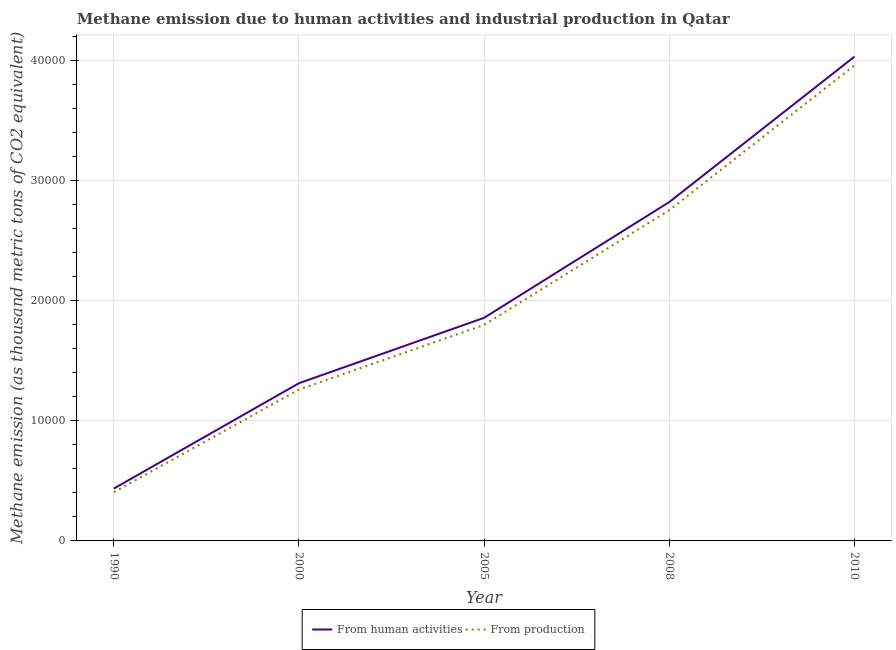How many different coloured lines are there?
Your response must be concise. 2. What is the amount of emissions from human activities in 2010?
Ensure brevity in your answer.  4.03e+04. Across all years, what is the maximum amount of emissions from human activities?
Make the answer very short. 4.03e+04. Across all years, what is the minimum amount of emissions generated from industries?
Offer a very short reply. 4055.8. In which year was the amount of emissions generated from industries minimum?
Ensure brevity in your answer.  1990. What is the total amount of emissions generated from industries in the graph?
Your answer should be very brief. 1.02e+05. What is the difference between the amount of emissions generated from industries in 2000 and that in 2005?
Make the answer very short. -5388.1. What is the difference between the amount of emissions generated from industries in 2010 and the amount of emissions from human activities in 1990?
Ensure brevity in your answer.  3.52e+04. What is the average amount of emissions from human activities per year?
Provide a short and direct response. 2.09e+04. In the year 2008, what is the difference between the amount of emissions generated from industries and amount of emissions from human activities?
Provide a succinct answer. -677. What is the ratio of the amount of emissions from human activities in 2005 to that in 2008?
Offer a terse response. 0.66. Is the amount of emissions generated from industries in 1990 less than that in 2000?
Make the answer very short. Yes. Is the difference between the amount of emissions generated from industries in 2005 and 2010 greater than the difference between the amount of emissions from human activities in 2005 and 2010?
Offer a terse response. Yes. What is the difference between the highest and the second highest amount of emissions generated from industries?
Your response must be concise. 1.21e+04. What is the difference between the highest and the lowest amount of emissions generated from industries?
Your answer should be very brief. 3.55e+04. In how many years, is the amount of emissions generated from industries greater than the average amount of emissions generated from industries taken over all years?
Your response must be concise. 2. Is the sum of the amount of emissions generated from industries in 2005 and 2008 greater than the maximum amount of emissions from human activities across all years?
Keep it short and to the point. Yes. How many lines are there?
Your answer should be compact. 2. How many years are there in the graph?
Offer a very short reply. 5. Are the values on the major ticks of Y-axis written in scientific E-notation?
Your response must be concise. No. Does the graph contain any zero values?
Ensure brevity in your answer.  No. How are the legend labels stacked?
Offer a terse response. Horizontal. What is the title of the graph?
Keep it short and to the point. Methane emission due to human activities and industrial production in Qatar. Does "Resident" appear as one of the legend labels in the graph?
Provide a succinct answer. No. What is the label or title of the X-axis?
Make the answer very short. Year. What is the label or title of the Y-axis?
Keep it short and to the point. Methane emission (as thousand metric tons of CO2 equivalent). What is the Methane emission (as thousand metric tons of CO2 equivalent) of From human activities in 1990?
Make the answer very short. 4358.8. What is the Methane emission (as thousand metric tons of CO2 equivalent) of From production in 1990?
Keep it short and to the point. 4055.8. What is the Methane emission (as thousand metric tons of CO2 equivalent) in From human activities in 2000?
Give a very brief answer. 1.31e+04. What is the Methane emission (as thousand metric tons of CO2 equivalent) of From production in 2000?
Ensure brevity in your answer.  1.26e+04. What is the Methane emission (as thousand metric tons of CO2 equivalent) of From human activities in 2005?
Ensure brevity in your answer.  1.86e+04. What is the Methane emission (as thousand metric tons of CO2 equivalent) of From production in 2005?
Your answer should be very brief. 1.80e+04. What is the Methane emission (as thousand metric tons of CO2 equivalent) in From human activities in 2008?
Give a very brief answer. 2.82e+04. What is the Methane emission (as thousand metric tons of CO2 equivalent) in From production in 2008?
Make the answer very short. 2.75e+04. What is the Methane emission (as thousand metric tons of CO2 equivalent) of From human activities in 2010?
Provide a succinct answer. 4.03e+04. What is the Methane emission (as thousand metric tons of CO2 equivalent) of From production in 2010?
Keep it short and to the point. 3.96e+04. Across all years, what is the maximum Methane emission (as thousand metric tons of CO2 equivalent) in From human activities?
Offer a very short reply. 4.03e+04. Across all years, what is the maximum Methane emission (as thousand metric tons of CO2 equivalent) of From production?
Your answer should be compact. 3.96e+04. Across all years, what is the minimum Methane emission (as thousand metric tons of CO2 equivalent) of From human activities?
Keep it short and to the point. 4358.8. Across all years, what is the minimum Methane emission (as thousand metric tons of CO2 equivalent) of From production?
Your answer should be very brief. 4055.8. What is the total Methane emission (as thousand metric tons of CO2 equivalent) in From human activities in the graph?
Make the answer very short. 1.05e+05. What is the total Methane emission (as thousand metric tons of CO2 equivalent) of From production in the graph?
Offer a very short reply. 1.02e+05. What is the difference between the Methane emission (as thousand metric tons of CO2 equivalent) of From human activities in 1990 and that in 2000?
Keep it short and to the point. -8774.7. What is the difference between the Methane emission (as thousand metric tons of CO2 equivalent) of From production in 1990 and that in 2000?
Your answer should be very brief. -8547.3. What is the difference between the Methane emission (as thousand metric tons of CO2 equivalent) in From human activities in 1990 and that in 2005?
Provide a succinct answer. -1.42e+04. What is the difference between the Methane emission (as thousand metric tons of CO2 equivalent) of From production in 1990 and that in 2005?
Give a very brief answer. -1.39e+04. What is the difference between the Methane emission (as thousand metric tons of CO2 equivalent) of From human activities in 1990 and that in 2008?
Provide a short and direct response. -2.39e+04. What is the difference between the Methane emission (as thousand metric tons of CO2 equivalent) in From production in 1990 and that in 2008?
Provide a succinct answer. -2.35e+04. What is the difference between the Methane emission (as thousand metric tons of CO2 equivalent) of From human activities in 1990 and that in 2010?
Your answer should be very brief. -3.60e+04. What is the difference between the Methane emission (as thousand metric tons of CO2 equivalent) in From production in 1990 and that in 2010?
Provide a succinct answer. -3.55e+04. What is the difference between the Methane emission (as thousand metric tons of CO2 equivalent) in From human activities in 2000 and that in 2005?
Provide a succinct answer. -5447.2. What is the difference between the Methane emission (as thousand metric tons of CO2 equivalent) of From production in 2000 and that in 2005?
Offer a very short reply. -5388.1. What is the difference between the Methane emission (as thousand metric tons of CO2 equivalent) in From human activities in 2000 and that in 2008?
Provide a short and direct response. -1.51e+04. What is the difference between the Methane emission (as thousand metric tons of CO2 equivalent) in From production in 2000 and that in 2008?
Provide a succinct answer. -1.49e+04. What is the difference between the Methane emission (as thousand metric tons of CO2 equivalent) in From human activities in 2000 and that in 2010?
Offer a very short reply. -2.72e+04. What is the difference between the Methane emission (as thousand metric tons of CO2 equivalent) in From production in 2000 and that in 2010?
Offer a terse response. -2.70e+04. What is the difference between the Methane emission (as thousand metric tons of CO2 equivalent) of From human activities in 2005 and that in 2008?
Your answer should be compact. -9640.9. What is the difference between the Methane emission (as thousand metric tons of CO2 equivalent) of From production in 2005 and that in 2008?
Give a very brief answer. -9553.4. What is the difference between the Methane emission (as thousand metric tons of CO2 equivalent) of From human activities in 2005 and that in 2010?
Provide a short and direct response. -2.17e+04. What is the difference between the Methane emission (as thousand metric tons of CO2 equivalent) in From production in 2005 and that in 2010?
Make the answer very short. -2.16e+04. What is the difference between the Methane emission (as thousand metric tons of CO2 equivalent) of From human activities in 2008 and that in 2010?
Provide a succinct answer. -1.21e+04. What is the difference between the Methane emission (as thousand metric tons of CO2 equivalent) of From production in 2008 and that in 2010?
Make the answer very short. -1.21e+04. What is the difference between the Methane emission (as thousand metric tons of CO2 equivalent) in From human activities in 1990 and the Methane emission (as thousand metric tons of CO2 equivalent) in From production in 2000?
Offer a terse response. -8244.3. What is the difference between the Methane emission (as thousand metric tons of CO2 equivalent) of From human activities in 1990 and the Methane emission (as thousand metric tons of CO2 equivalent) of From production in 2005?
Provide a short and direct response. -1.36e+04. What is the difference between the Methane emission (as thousand metric tons of CO2 equivalent) in From human activities in 1990 and the Methane emission (as thousand metric tons of CO2 equivalent) in From production in 2008?
Offer a very short reply. -2.32e+04. What is the difference between the Methane emission (as thousand metric tons of CO2 equivalent) of From human activities in 1990 and the Methane emission (as thousand metric tons of CO2 equivalent) of From production in 2010?
Make the answer very short. -3.52e+04. What is the difference between the Methane emission (as thousand metric tons of CO2 equivalent) of From human activities in 2000 and the Methane emission (as thousand metric tons of CO2 equivalent) of From production in 2005?
Your answer should be very brief. -4857.7. What is the difference between the Methane emission (as thousand metric tons of CO2 equivalent) in From human activities in 2000 and the Methane emission (as thousand metric tons of CO2 equivalent) in From production in 2008?
Keep it short and to the point. -1.44e+04. What is the difference between the Methane emission (as thousand metric tons of CO2 equivalent) in From human activities in 2000 and the Methane emission (as thousand metric tons of CO2 equivalent) in From production in 2010?
Offer a very short reply. -2.65e+04. What is the difference between the Methane emission (as thousand metric tons of CO2 equivalent) in From human activities in 2005 and the Methane emission (as thousand metric tons of CO2 equivalent) in From production in 2008?
Offer a terse response. -8963.9. What is the difference between the Methane emission (as thousand metric tons of CO2 equivalent) of From human activities in 2005 and the Methane emission (as thousand metric tons of CO2 equivalent) of From production in 2010?
Your response must be concise. -2.10e+04. What is the difference between the Methane emission (as thousand metric tons of CO2 equivalent) of From human activities in 2008 and the Methane emission (as thousand metric tons of CO2 equivalent) of From production in 2010?
Ensure brevity in your answer.  -1.14e+04. What is the average Methane emission (as thousand metric tons of CO2 equivalent) in From human activities per year?
Ensure brevity in your answer.  2.09e+04. What is the average Methane emission (as thousand metric tons of CO2 equivalent) in From production per year?
Make the answer very short. 2.04e+04. In the year 1990, what is the difference between the Methane emission (as thousand metric tons of CO2 equivalent) of From human activities and Methane emission (as thousand metric tons of CO2 equivalent) of From production?
Your answer should be compact. 303. In the year 2000, what is the difference between the Methane emission (as thousand metric tons of CO2 equivalent) of From human activities and Methane emission (as thousand metric tons of CO2 equivalent) of From production?
Your answer should be very brief. 530.4. In the year 2005, what is the difference between the Methane emission (as thousand metric tons of CO2 equivalent) in From human activities and Methane emission (as thousand metric tons of CO2 equivalent) in From production?
Keep it short and to the point. 589.5. In the year 2008, what is the difference between the Methane emission (as thousand metric tons of CO2 equivalent) of From human activities and Methane emission (as thousand metric tons of CO2 equivalent) of From production?
Offer a terse response. 677. In the year 2010, what is the difference between the Methane emission (as thousand metric tons of CO2 equivalent) of From human activities and Methane emission (as thousand metric tons of CO2 equivalent) of From production?
Your answer should be very brief. 728. What is the ratio of the Methane emission (as thousand metric tons of CO2 equivalent) in From human activities in 1990 to that in 2000?
Your answer should be compact. 0.33. What is the ratio of the Methane emission (as thousand metric tons of CO2 equivalent) in From production in 1990 to that in 2000?
Offer a terse response. 0.32. What is the ratio of the Methane emission (as thousand metric tons of CO2 equivalent) in From human activities in 1990 to that in 2005?
Provide a short and direct response. 0.23. What is the ratio of the Methane emission (as thousand metric tons of CO2 equivalent) of From production in 1990 to that in 2005?
Provide a short and direct response. 0.23. What is the ratio of the Methane emission (as thousand metric tons of CO2 equivalent) of From human activities in 1990 to that in 2008?
Provide a succinct answer. 0.15. What is the ratio of the Methane emission (as thousand metric tons of CO2 equivalent) of From production in 1990 to that in 2008?
Your answer should be very brief. 0.15. What is the ratio of the Methane emission (as thousand metric tons of CO2 equivalent) of From human activities in 1990 to that in 2010?
Your response must be concise. 0.11. What is the ratio of the Methane emission (as thousand metric tons of CO2 equivalent) in From production in 1990 to that in 2010?
Provide a short and direct response. 0.1. What is the ratio of the Methane emission (as thousand metric tons of CO2 equivalent) in From human activities in 2000 to that in 2005?
Your response must be concise. 0.71. What is the ratio of the Methane emission (as thousand metric tons of CO2 equivalent) in From production in 2000 to that in 2005?
Your answer should be compact. 0.7. What is the ratio of the Methane emission (as thousand metric tons of CO2 equivalent) of From human activities in 2000 to that in 2008?
Offer a very short reply. 0.47. What is the ratio of the Methane emission (as thousand metric tons of CO2 equivalent) of From production in 2000 to that in 2008?
Ensure brevity in your answer.  0.46. What is the ratio of the Methane emission (as thousand metric tons of CO2 equivalent) of From human activities in 2000 to that in 2010?
Give a very brief answer. 0.33. What is the ratio of the Methane emission (as thousand metric tons of CO2 equivalent) in From production in 2000 to that in 2010?
Give a very brief answer. 0.32. What is the ratio of the Methane emission (as thousand metric tons of CO2 equivalent) of From human activities in 2005 to that in 2008?
Your answer should be very brief. 0.66. What is the ratio of the Methane emission (as thousand metric tons of CO2 equivalent) of From production in 2005 to that in 2008?
Offer a terse response. 0.65. What is the ratio of the Methane emission (as thousand metric tons of CO2 equivalent) in From human activities in 2005 to that in 2010?
Your answer should be very brief. 0.46. What is the ratio of the Methane emission (as thousand metric tons of CO2 equivalent) of From production in 2005 to that in 2010?
Provide a short and direct response. 0.45. What is the ratio of the Methane emission (as thousand metric tons of CO2 equivalent) in From human activities in 2008 to that in 2010?
Make the answer very short. 0.7. What is the ratio of the Methane emission (as thousand metric tons of CO2 equivalent) in From production in 2008 to that in 2010?
Make the answer very short. 0.7. What is the difference between the highest and the second highest Methane emission (as thousand metric tons of CO2 equivalent) in From human activities?
Provide a short and direct response. 1.21e+04. What is the difference between the highest and the second highest Methane emission (as thousand metric tons of CO2 equivalent) of From production?
Offer a very short reply. 1.21e+04. What is the difference between the highest and the lowest Methane emission (as thousand metric tons of CO2 equivalent) in From human activities?
Offer a very short reply. 3.60e+04. What is the difference between the highest and the lowest Methane emission (as thousand metric tons of CO2 equivalent) of From production?
Make the answer very short. 3.55e+04. 